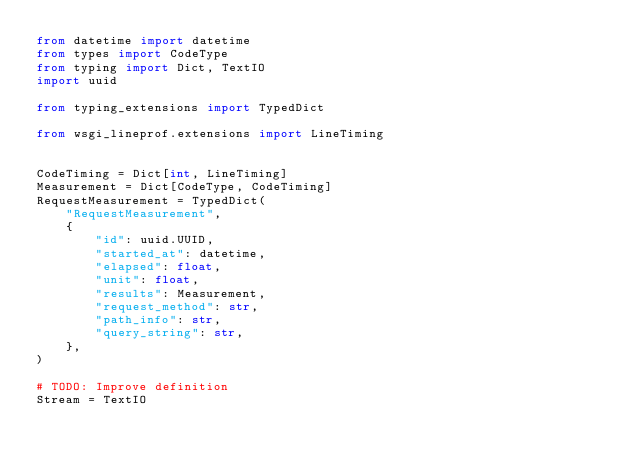Convert code to text. <code><loc_0><loc_0><loc_500><loc_500><_Python_>from datetime import datetime
from types import CodeType
from typing import Dict, TextIO
import uuid

from typing_extensions import TypedDict

from wsgi_lineprof.extensions import LineTiming


CodeTiming = Dict[int, LineTiming]
Measurement = Dict[CodeType, CodeTiming]
RequestMeasurement = TypedDict(
    "RequestMeasurement",
    {
        "id": uuid.UUID,
        "started_at": datetime,
        "elapsed": float,
        "unit": float,
        "results": Measurement,
        "request_method": str,
        "path_info": str,
        "query_string": str,
    },
)

# TODO: Improve definition
Stream = TextIO
</code> 